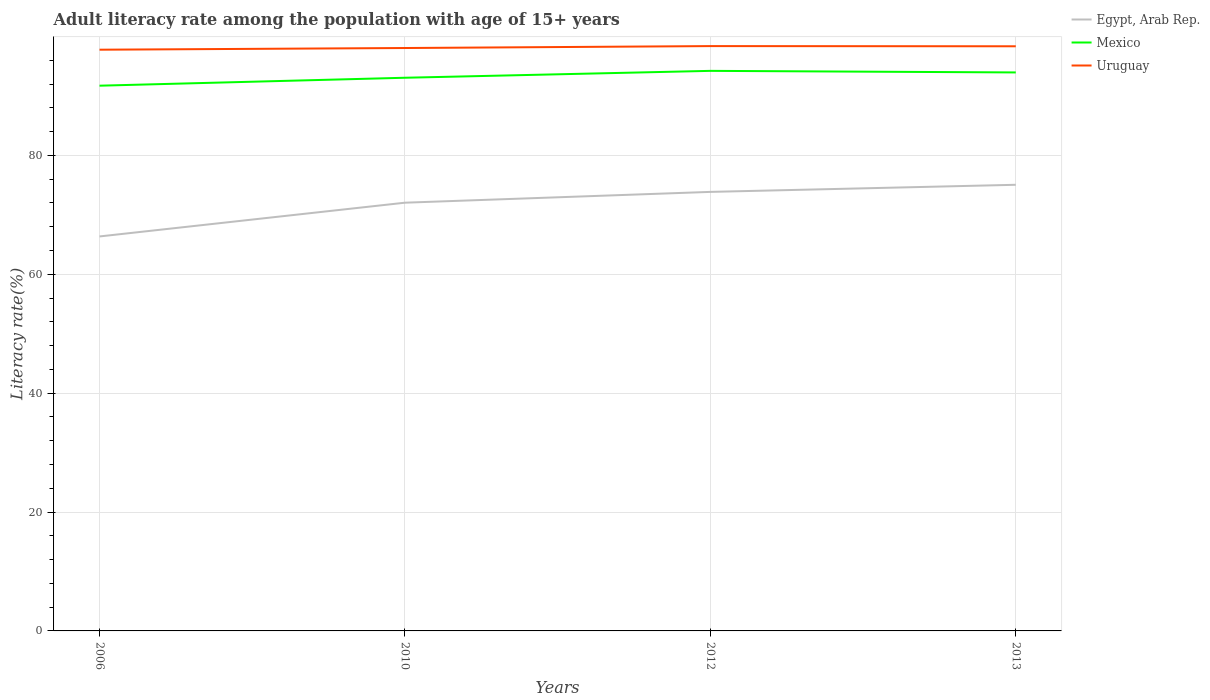How many different coloured lines are there?
Give a very brief answer. 3. Across all years, what is the maximum adult literacy rate in Egypt, Arab Rep.?
Offer a terse response. 66.37. What is the total adult literacy rate in Egypt, Arab Rep. in the graph?
Make the answer very short. -1.82. What is the difference between the highest and the second highest adult literacy rate in Uruguay?
Your answer should be very brief. 0.61. What is the difference between the highest and the lowest adult literacy rate in Mexico?
Ensure brevity in your answer.  2. Is the adult literacy rate in Uruguay strictly greater than the adult literacy rate in Mexico over the years?
Offer a very short reply. No. How many years are there in the graph?
Provide a short and direct response. 4. What is the difference between two consecutive major ticks on the Y-axis?
Offer a very short reply. 20. Are the values on the major ticks of Y-axis written in scientific E-notation?
Your response must be concise. No. Does the graph contain grids?
Your response must be concise. Yes. What is the title of the graph?
Offer a very short reply. Adult literacy rate among the population with age of 15+ years. What is the label or title of the Y-axis?
Your answer should be compact. Literacy rate(%). What is the Literacy rate(%) in Egypt, Arab Rep. in 2006?
Offer a very short reply. 66.37. What is the Literacy rate(%) of Mexico in 2006?
Your response must be concise. 91.73. What is the Literacy rate(%) of Uruguay in 2006?
Offer a terse response. 97.79. What is the Literacy rate(%) in Egypt, Arab Rep. in 2010?
Make the answer very short. 72.05. What is the Literacy rate(%) of Mexico in 2010?
Provide a succinct answer. 93.07. What is the Literacy rate(%) of Uruguay in 2010?
Ensure brevity in your answer.  98.07. What is the Literacy rate(%) in Egypt, Arab Rep. in 2012?
Offer a very short reply. 73.87. What is the Literacy rate(%) of Mexico in 2012?
Offer a terse response. 94.23. What is the Literacy rate(%) in Uruguay in 2012?
Provide a short and direct response. 98.4. What is the Literacy rate(%) in Egypt, Arab Rep. in 2013?
Keep it short and to the point. 75.06. What is the Literacy rate(%) of Mexico in 2013?
Offer a terse response. 93.96. What is the Literacy rate(%) of Uruguay in 2013?
Ensure brevity in your answer.  98.36. Across all years, what is the maximum Literacy rate(%) in Egypt, Arab Rep.?
Provide a short and direct response. 75.06. Across all years, what is the maximum Literacy rate(%) in Mexico?
Give a very brief answer. 94.23. Across all years, what is the maximum Literacy rate(%) in Uruguay?
Your response must be concise. 98.4. Across all years, what is the minimum Literacy rate(%) in Egypt, Arab Rep.?
Keep it short and to the point. 66.37. Across all years, what is the minimum Literacy rate(%) in Mexico?
Offer a very short reply. 91.73. Across all years, what is the minimum Literacy rate(%) of Uruguay?
Offer a terse response. 97.79. What is the total Literacy rate(%) of Egypt, Arab Rep. in the graph?
Make the answer very short. 287.34. What is the total Literacy rate(%) of Mexico in the graph?
Make the answer very short. 372.99. What is the total Literacy rate(%) of Uruguay in the graph?
Your response must be concise. 392.62. What is the difference between the Literacy rate(%) in Egypt, Arab Rep. in 2006 and that in 2010?
Provide a succinct answer. -5.68. What is the difference between the Literacy rate(%) of Mexico in 2006 and that in 2010?
Your response must be concise. -1.33. What is the difference between the Literacy rate(%) in Uruguay in 2006 and that in 2010?
Provide a succinct answer. -0.28. What is the difference between the Literacy rate(%) in Egypt, Arab Rep. in 2006 and that in 2012?
Provide a succinct answer. -7.5. What is the difference between the Literacy rate(%) in Mexico in 2006 and that in 2012?
Your response must be concise. -2.49. What is the difference between the Literacy rate(%) in Uruguay in 2006 and that in 2012?
Your answer should be very brief. -0.61. What is the difference between the Literacy rate(%) of Egypt, Arab Rep. in 2006 and that in 2013?
Make the answer very short. -8.69. What is the difference between the Literacy rate(%) of Mexico in 2006 and that in 2013?
Give a very brief answer. -2.23. What is the difference between the Literacy rate(%) of Uruguay in 2006 and that in 2013?
Offer a terse response. -0.57. What is the difference between the Literacy rate(%) in Egypt, Arab Rep. in 2010 and that in 2012?
Your answer should be compact. -1.82. What is the difference between the Literacy rate(%) in Mexico in 2010 and that in 2012?
Offer a very short reply. -1.16. What is the difference between the Literacy rate(%) in Uruguay in 2010 and that in 2012?
Your answer should be very brief. -0.32. What is the difference between the Literacy rate(%) of Egypt, Arab Rep. in 2010 and that in 2013?
Provide a succinct answer. -3.01. What is the difference between the Literacy rate(%) in Mexico in 2010 and that in 2013?
Make the answer very short. -0.89. What is the difference between the Literacy rate(%) in Uruguay in 2010 and that in 2013?
Offer a very short reply. -0.29. What is the difference between the Literacy rate(%) of Egypt, Arab Rep. in 2012 and that in 2013?
Ensure brevity in your answer.  -1.2. What is the difference between the Literacy rate(%) in Mexico in 2012 and that in 2013?
Provide a succinct answer. 0.27. What is the difference between the Literacy rate(%) in Uruguay in 2012 and that in 2013?
Provide a short and direct response. 0.03. What is the difference between the Literacy rate(%) in Egypt, Arab Rep. in 2006 and the Literacy rate(%) in Mexico in 2010?
Your response must be concise. -26.7. What is the difference between the Literacy rate(%) of Egypt, Arab Rep. in 2006 and the Literacy rate(%) of Uruguay in 2010?
Your answer should be compact. -31.7. What is the difference between the Literacy rate(%) in Mexico in 2006 and the Literacy rate(%) in Uruguay in 2010?
Make the answer very short. -6.34. What is the difference between the Literacy rate(%) in Egypt, Arab Rep. in 2006 and the Literacy rate(%) in Mexico in 2012?
Your response must be concise. -27.86. What is the difference between the Literacy rate(%) of Egypt, Arab Rep. in 2006 and the Literacy rate(%) of Uruguay in 2012?
Make the answer very short. -32.03. What is the difference between the Literacy rate(%) in Mexico in 2006 and the Literacy rate(%) in Uruguay in 2012?
Your response must be concise. -6.66. What is the difference between the Literacy rate(%) of Egypt, Arab Rep. in 2006 and the Literacy rate(%) of Mexico in 2013?
Give a very brief answer. -27.59. What is the difference between the Literacy rate(%) in Egypt, Arab Rep. in 2006 and the Literacy rate(%) in Uruguay in 2013?
Make the answer very short. -31.99. What is the difference between the Literacy rate(%) of Mexico in 2006 and the Literacy rate(%) of Uruguay in 2013?
Your response must be concise. -6.63. What is the difference between the Literacy rate(%) in Egypt, Arab Rep. in 2010 and the Literacy rate(%) in Mexico in 2012?
Make the answer very short. -22.18. What is the difference between the Literacy rate(%) in Egypt, Arab Rep. in 2010 and the Literacy rate(%) in Uruguay in 2012?
Offer a very short reply. -26.35. What is the difference between the Literacy rate(%) in Mexico in 2010 and the Literacy rate(%) in Uruguay in 2012?
Make the answer very short. -5.33. What is the difference between the Literacy rate(%) in Egypt, Arab Rep. in 2010 and the Literacy rate(%) in Mexico in 2013?
Make the answer very short. -21.91. What is the difference between the Literacy rate(%) in Egypt, Arab Rep. in 2010 and the Literacy rate(%) in Uruguay in 2013?
Your answer should be compact. -26.32. What is the difference between the Literacy rate(%) of Mexico in 2010 and the Literacy rate(%) of Uruguay in 2013?
Provide a short and direct response. -5.29. What is the difference between the Literacy rate(%) of Egypt, Arab Rep. in 2012 and the Literacy rate(%) of Mexico in 2013?
Ensure brevity in your answer.  -20.1. What is the difference between the Literacy rate(%) of Egypt, Arab Rep. in 2012 and the Literacy rate(%) of Uruguay in 2013?
Keep it short and to the point. -24.5. What is the difference between the Literacy rate(%) of Mexico in 2012 and the Literacy rate(%) of Uruguay in 2013?
Your response must be concise. -4.14. What is the average Literacy rate(%) of Egypt, Arab Rep. per year?
Your answer should be compact. 71.84. What is the average Literacy rate(%) of Mexico per year?
Keep it short and to the point. 93.25. What is the average Literacy rate(%) in Uruguay per year?
Your answer should be compact. 98.16. In the year 2006, what is the difference between the Literacy rate(%) of Egypt, Arab Rep. and Literacy rate(%) of Mexico?
Offer a very short reply. -25.36. In the year 2006, what is the difference between the Literacy rate(%) in Egypt, Arab Rep. and Literacy rate(%) in Uruguay?
Your answer should be very brief. -31.42. In the year 2006, what is the difference between the Literacy rate(%) in Mexico and Literacy rate(%) in Uruguay?
Ensure brevity in your answer.  -6.06. In the year 2010, what is the difference between the Literacy rate(%) of Egypt, Arab Rep. and Literacy rate(%) of Mexico?
Your answer should be very brief. -21.02. In the year 2010, what is the difference between the Literacy rate(%) in Egypt, Arab Rep. and Literacy rate(%) in Uruguay?
Your response must be concise. -26.02. In the year 2010, what is the difference between the Literacy rate(%) of Mexico and Literacy rate(%) of Uruguay?
Offer a terse response. -5. In the year 2012, what is the difference between the Literacy rate(%) in Egypt, Arab Rep. and Literacy rate(%) in Mexico?
Ensure brevity in your answer.  -20.36. In the year 2012, what is the difference between the Literacy rate(%) of Egypt, Arab Rep. and Literacy rate(%) of Uruguay?
Ensure brevity in your answer.  -24.53. In the year 2012, what is the difference between the Literacy rate(%) in Mexico and Literacy rate(%) in Uruguay?
Your answer should be compact. -4.17. In the year 2013, what is the difference between the Literacy rate(%) in Egypt, Arab Rep. and Literacy rate(%) in Mexico?
Your response must be concise. -18.9. In the year 2013, what is the difference between the Literacy rate(%) in Egypt, Arab Rep. and Literacy rate(%) in Uruguay?
Provide a succinct answer. -23.3. In the year 2013, what is the difference between the Literacy rate(%) in Mexico and Literacy rate(%) in Uruguay?
Keep it short and to the point. -4.4. What is the ratio of the Literacy rate(%) of Egypt, Arab Rep. in 2006 to that in 2010?
Your answer should be compact. 0.92. What is the ratio of the Literacy rate(%) of Mexico in 2006 to that in 2010?
Give a very brief answer. 0.99. What is the ratio of the Literacy rate(%) in Egypt, Arab Rep. in 2006 to that in 2012?
Keep it short and to the point. 0.9. What is the ratio of the Literacy rate(%) in Mexico in 2006 to that in 2012?
Give a very brief answer. 0.97. What is the ratio of the Literacy rate(%) in Egypt, Arab Rep. in 2006 to that in 2013?
Provide a short and direct response. 0.88. What is the ratio of the Literacy rate(%) of Mexico in 2006 to that in 2013?
Provide a short and direct response. 0.98. What is the ratio of the Literacy rate(%) of Uruguay in 2006 to that in 2013?
Provide a short and direct response. 0.99. What is the ratio of the Literacy rate(%) of Egypt, Arab Rep. in 2010 to that in 2012?
Provide a short and direct response. 0.98. What is the ratio of the Literacy rate(%) in Uruguay in 2010 to that in 2012?
Offer a very short reply. 1. What is the ratio of the Literacy rate(%) in Egypt, Arab Rep. in 2010 to that in 2013?
Offer a very short reply. 0.96. What is the ratio of the Literacy rate(%) of Egypt, Arab Rep. in 2012 to that in 2013?
Give a very brief answer. 0.98. What is the ratio of the Literacy rate(%) of Mexico in 2012 to that in 2013?
Provide a succinct answer. 1. What is the ratio of the Literacy rate(%) of Uruguay in 2012 to that in 2013?
Your answer should be compact. 1. What is the difference between the highest and the second highest Literacy rate(%) of Egypt, Arab Rep.?
Your answer should be very brief. 1.2. What is the difference between the highest and the second highest Literacy rate(%) in Mexico?
Make the answer very short. 0.27. What is the difference between the highest and the second highest Literacy rate(%) of Uruguay?
Offer a terse response. 0.03. What is the difference between the highest and the lowest Literacy rate(%) of Egypt, Arab Rep.?
Provide a succinct answer. 8.69. What is the difference between the highest and the lowest Literacy rate(%) of Mexico?
Your answer should be compact. 2.49. What is the difference between the highest and the lowest Literacy rate(%) in Uruguay?
Your answer should be very brief. 0.61. 